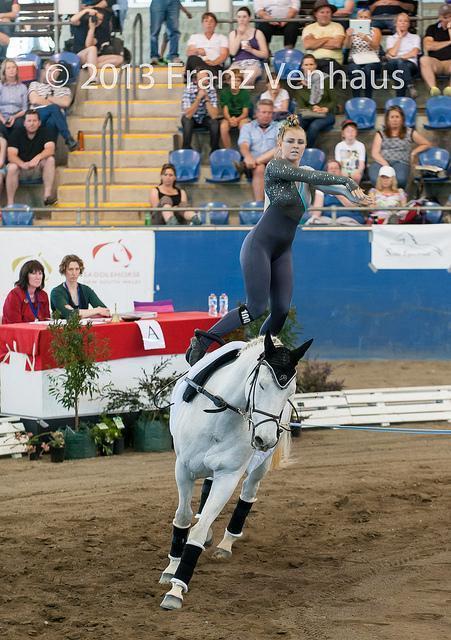How many people are there?
Give a very brief answer. 9. How many potted plants can you see?
Give a very brief answer. 2. 